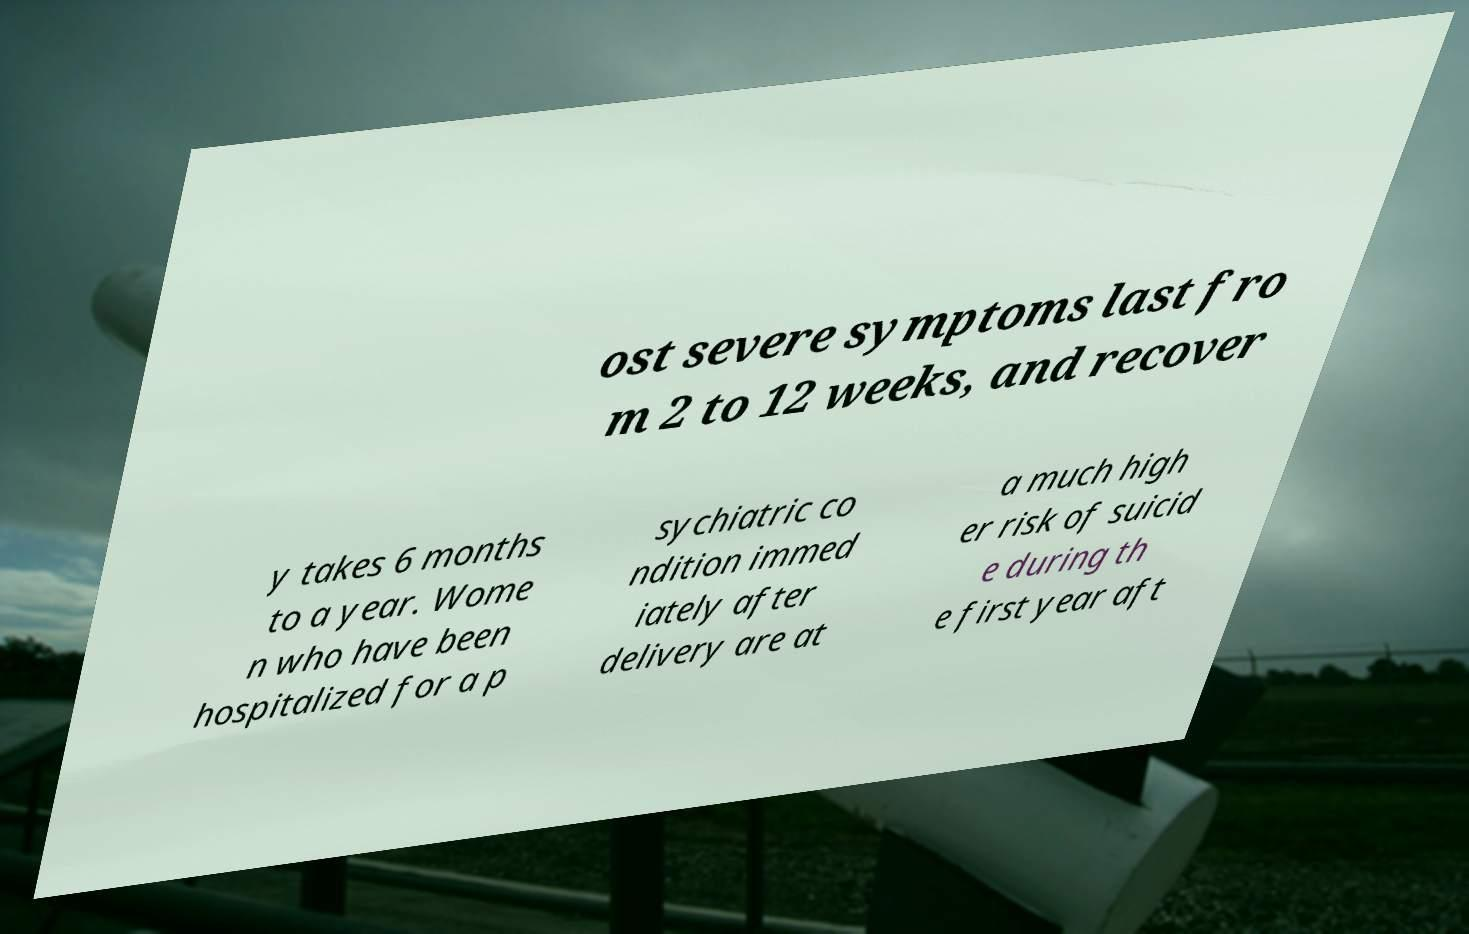Please identify and transcribe the text found in this image. ost severe symptoms last fro m 2 to 12 weeks, and recover y takes 6 months to a year. Wome n who have been hospitalized for a p sychiatric co ndition immed iately after delivery are at a much high er risk of suicid e during th e first year aft 